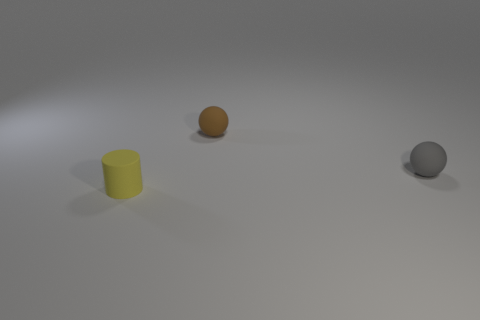Add 1 yellow cylinders. How many objects exist? 4 Subtract all balls. How many objects are left? 1 Add 3 gray balls. How many gray balls are left? 4 Add 1 large yellow matte balls. How many large yellow matte balls exist? 1 Subtract all brown spheres. How many spheres are left? 1 Subtract 0 red spheres. How many objects are left? 3 Subtract all blue spheres. Subtract all purple cylinders. How many spheres are left? 2 Subtract all brown cylinders. How many gray spheres are left? 1 Subtract all tiny gray objects. Subtract all gray rubber objects. How many objects are left? 1 